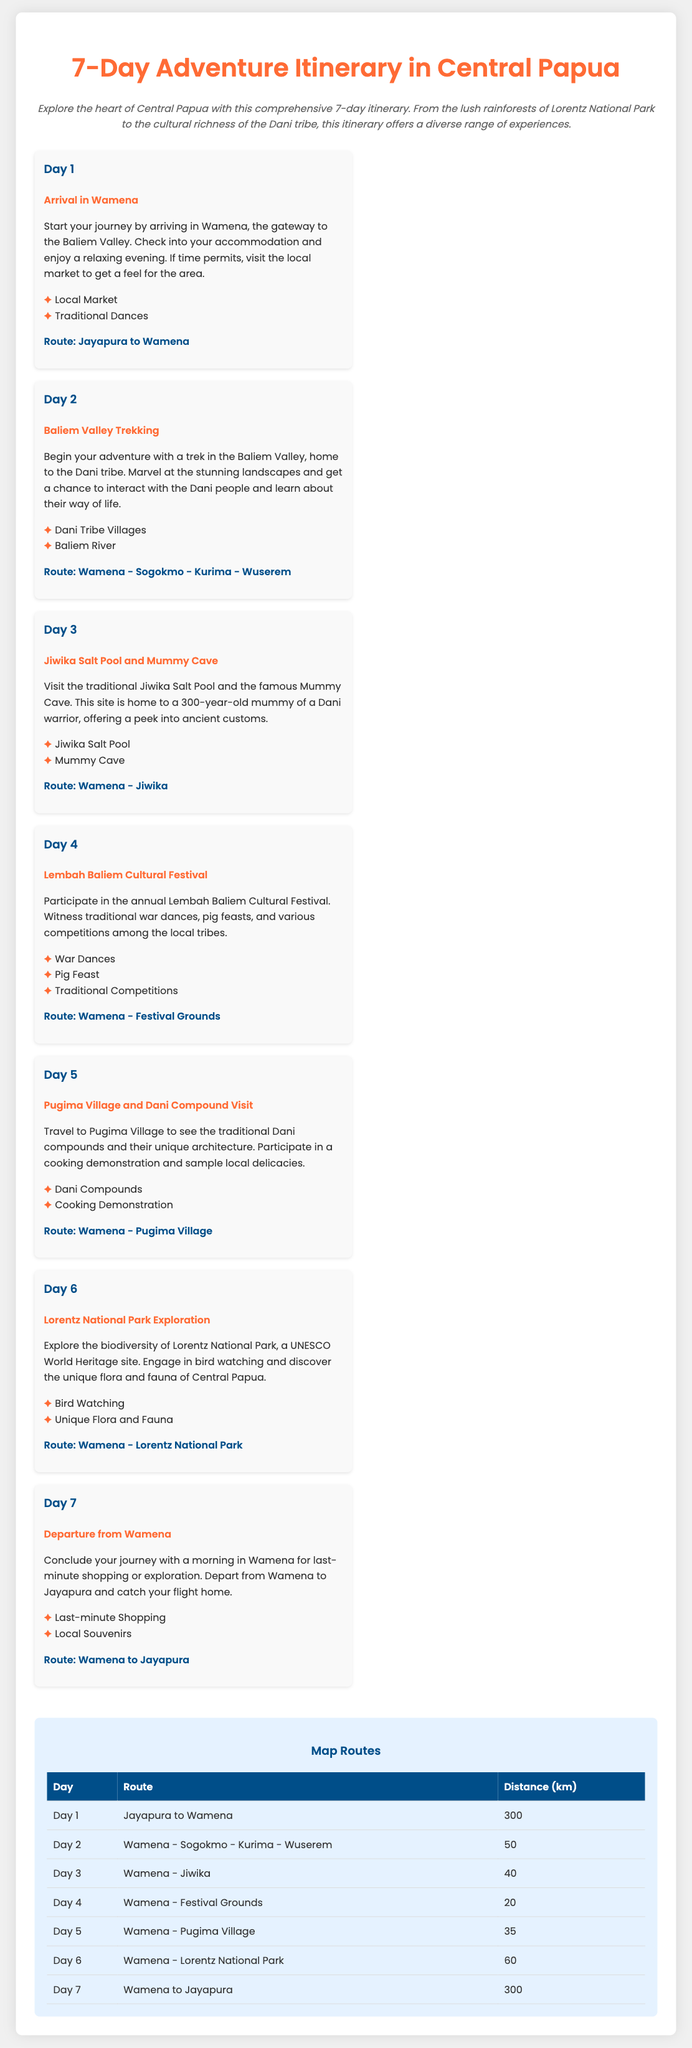What is the title of the document? The title, as stated in the document, is prominently displayed at the top of the page.
Answer: 7-Day Adventure Itinerary in Central Papua What is the route for Day 3? Each day includes a route description that details the travel path for that specific day.
Answer: Wamena - Jiwika How many kilometers is the travel on Day 2? The distance for each day is provided in a table summarizing the routes and distances covered.
Answer: 50 What cultural festival is celebrated on Day 4? The itinerary highlights noteworthy events, including cultural festivals, each linked to specific days.
Answer: Lembah Baliem Cultural Festival What wildlife activity is included in Day 6? Each day lists activities, and Day 6 focuses on a particular interest related to biodiversity.
Answer: Bird Watching On which day does departure from Wamena occur? The itinerary clearly states the activities for each day, including the last day of travel.
Answer: Day 7 List one highlight from Day 5. The highlights section for each day showcases the key experiences one can expect, making them easily identifiable.
Answer: Cooking Demonstration What is unique about the Mummy Cave mentioned? The document describes significant sites along with their historical or cultural relevance.
Answer: 300-year-old mummy of a Dani warrior 